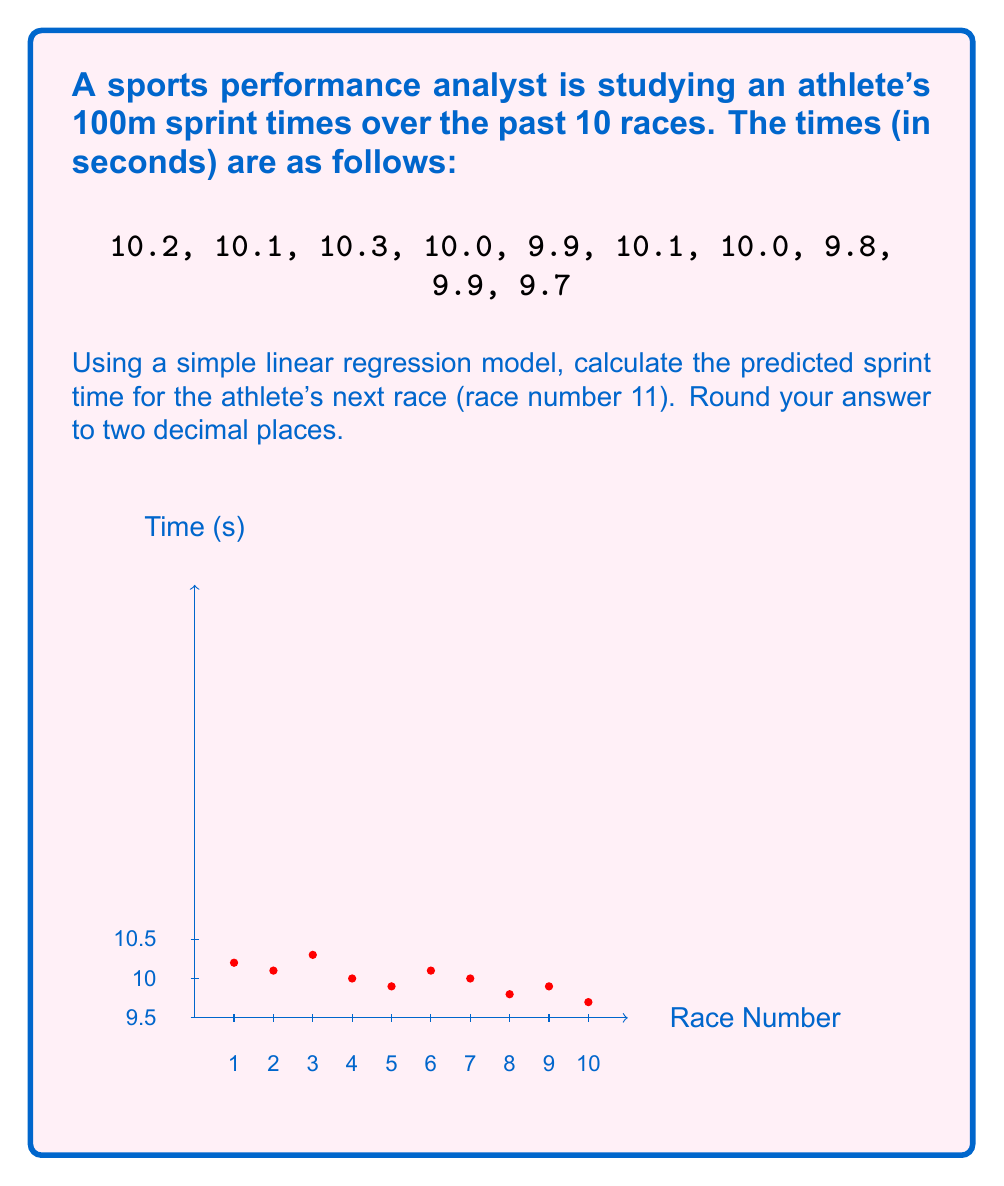Provide a solution to this math problem. To solve this problem, we'll use the simple linear regression model:

$$ y = mx + b $$

Where $y$ is the sprint time, $x$ is the race number, $m$ is the slope, and $b$ is the y-intercept.

Step 1: Calculate the mean of x and y
$\bar{x} = \frac{1+2+3+4+5+6+7+8+9+10}{10} = 5.5$
$\bar{y} = \frac{10.2+10.1+10.3+10.0+9.9+10.1+10.0+9.8+9.9+9.7}{10} = 10$

Step 2: Calculate the slope (m)
$m = \frac{\sum(x_i - \bar{x})(y_i - \bar{y})}{\sum(x_i - \bar{x})^2}$

$\sum(x_i - \bar{x})(y_i - \bar{y}) = -2.75$
$\sum(x_i - \bar{x})^2 = 82.5$

$m = \frac{-2.75}{82.5} = -0.0333333$

Step 3: Calculate the y-intercept (b)
$b = \bar{y} - m\bar{x} = 10 - (-0.0333333 \times 5.5) = 10.1833333$

Step 4: Use the regression equation to predict the next race time
$y = mx + b$
$y = -0.0333333 \times 11 + 10.1833333 = 9.8166667$

Rounding to two decimal places: 9.82 seconds
Answer: 9.82 seconds 